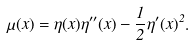<formula> <loc_0><loc_0><loc_500><loc_500>\quad \mu ( x ) = \eta ( x ) \eta ^ { \prime \prime } ( x ) - \frac { 1 } { 2 } \eta ^ { \prime } ( x ) ^ { 2 } .</formula> 